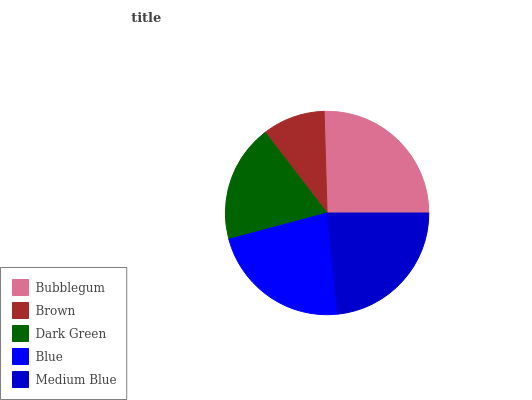Is Brown the minimum?
Answer yes or no. Yes. Is Bubblegum the maximum?
Answer yes or no. Yes. Is Dark Green the minimum?
Answer yes or no. No. Is Dark Green the maximum?
Answer yes or no. No. Is Dark Green greater than Brown?
Answer yes or no. Yes. Is Brown less than Dark Green?
Answer yes or no. Yes. Is Brown greater than Dark Green?
Answer yes or no. No. Is Dark Green less than Brown?
Answer yes or no. No. Is Blue the high median?
Answer yes or no. Yes. Is Blue the low median?
Answer yes or no. Yes. Is Medium Blue the high median?
Answer yes or no. No. Is Dark Green the low median?
Answer yes or no. No. 